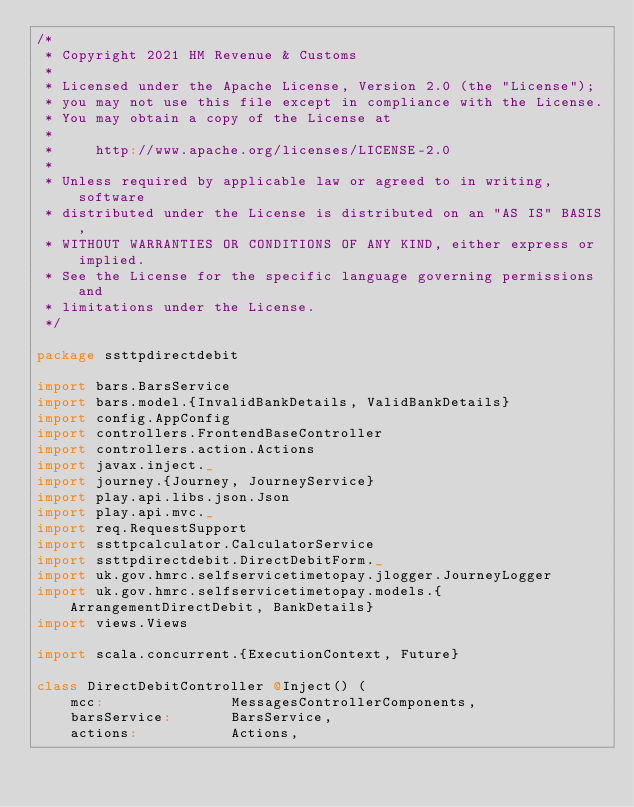<code> <loc_0><loc_0><loc_500><loc_500><_Scala_>/*
 * Copyright 2021 HM Revenue & Customs
 *
 * Licensed under the Apache License, Version 2.0 (the "License");
 * you may not use this file except in compliance with the License.
 * You may obtain a copy of the License at
 *
 *     http://www.apache.org/licenses/LICENSE-2.0
 *
 * Unless required by applicable law or agreed to in writing, software
 * distributed under the License is distributed on an "AS IS" BASIS,
 * WITHOUT WARRANTIES OR CONDITIONS OF ANY KIND, either express or implied.
 * See the License for the specific language governing permissions and
 * limitations under the License.
 */

package ssttpdirectdebit

import bars.BarsService
import bars.model.{InvalidBankDetails, ValidBankDetails}
import config.AppConfig
import controllers.FrontendBaseController
import controllers.action.Actions
import javax.inject._
import journey.{Journey, JourneyService}
import play.api.libs.json.Json
import play.api.mvc._
import req.RequestSupport
import ssttpcalculator.CalculatorService
import ssttpdirectdebit.DirectDebitForm._
import uk.gov.hmrc.selfservicetimetopay.jlogger.JourneyLogger
import uk.gov.hmrc.selfservicetimetopay.models.{ArrangementDirectDebit, BankDetails}
import views.Views

import scala.concurrent.{ExecutionContext, Future}

class DirectDebitController @Inject() (
    mcc:               MessagesControllerComponents,
    barsService:       BarsService,
    actions:           Actions,</code> 